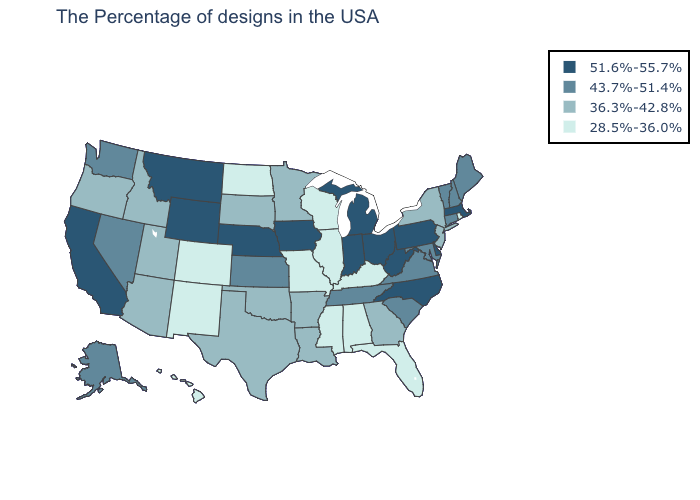Name the states that have a value in the range 51.6%-55.7%?
Short answer required. Massachusetts, Delaware, Pennsylvania, North Carolina, West Virginia, Ohio, Michigan, Indiana, Iowa, Nebraska, Wyoming, Montana, California. Which states have the lowest value in the USA?
Write a very short answer. Rhode Island, Florida, Kentucky, Alabama, Wisconsin, Illinois, Mississippi, Missouri, North Dakota, Colorado, New Mexico, Hawaii. Does the map have missing data?
Short answer required. No. Does the first symbol in the legend represent the smallest category?
Give a very brief answer. No. Name the states that have a value in the range 36.3%-42.8%?
Short answer required. New York, New Jersey, Georgia, Louisiana, Arkansas, Minnesota, Oklahoma, Texas, South Dakota, Utah, Arizona, Idaho, Oregon. Does Connecticut have the lowest value in the USA?
Be succinct. No. What is the lowest value in states that border Ohio?
Give a very brief answer. 28.5%-36.0%. Among the states that border Illinois , which have the highest value?
Give a very brief answer. Indiana, Iowa. Name the states that have a value in the range 51.6%-55.7%?
Quick response, please. Massachusetts, Delaware, Pennsylvania, North Carolina, West Virginia, Ohio, Michigan, Indiana, Iowa, Nebraska, Wyoming, Montana, California. Among the states that border New Mexico , does Arizona have the lowest value?
Keep it brief. No. What is the highest value in the South ?
Write a very short answer. 51.6%-55.7%. Name the states that have a value in the range 28.5%-36.0%?
Short answer required. Rhode Island, Florida, Kentucky, Alabama, Wisconsin, Illinois, Mississippi, Missouri, North Dakota, Colorado, New Mexico, Hawaii. What is the value of Florida?
Give a very brief answer. 28.5%-36.0%. What is the lowest value in the Northeast?
Answer briefly. 28.5%-36.0%. What is the value of Nebraska?
Give a very brief answer. 51.6%-55.7%. 